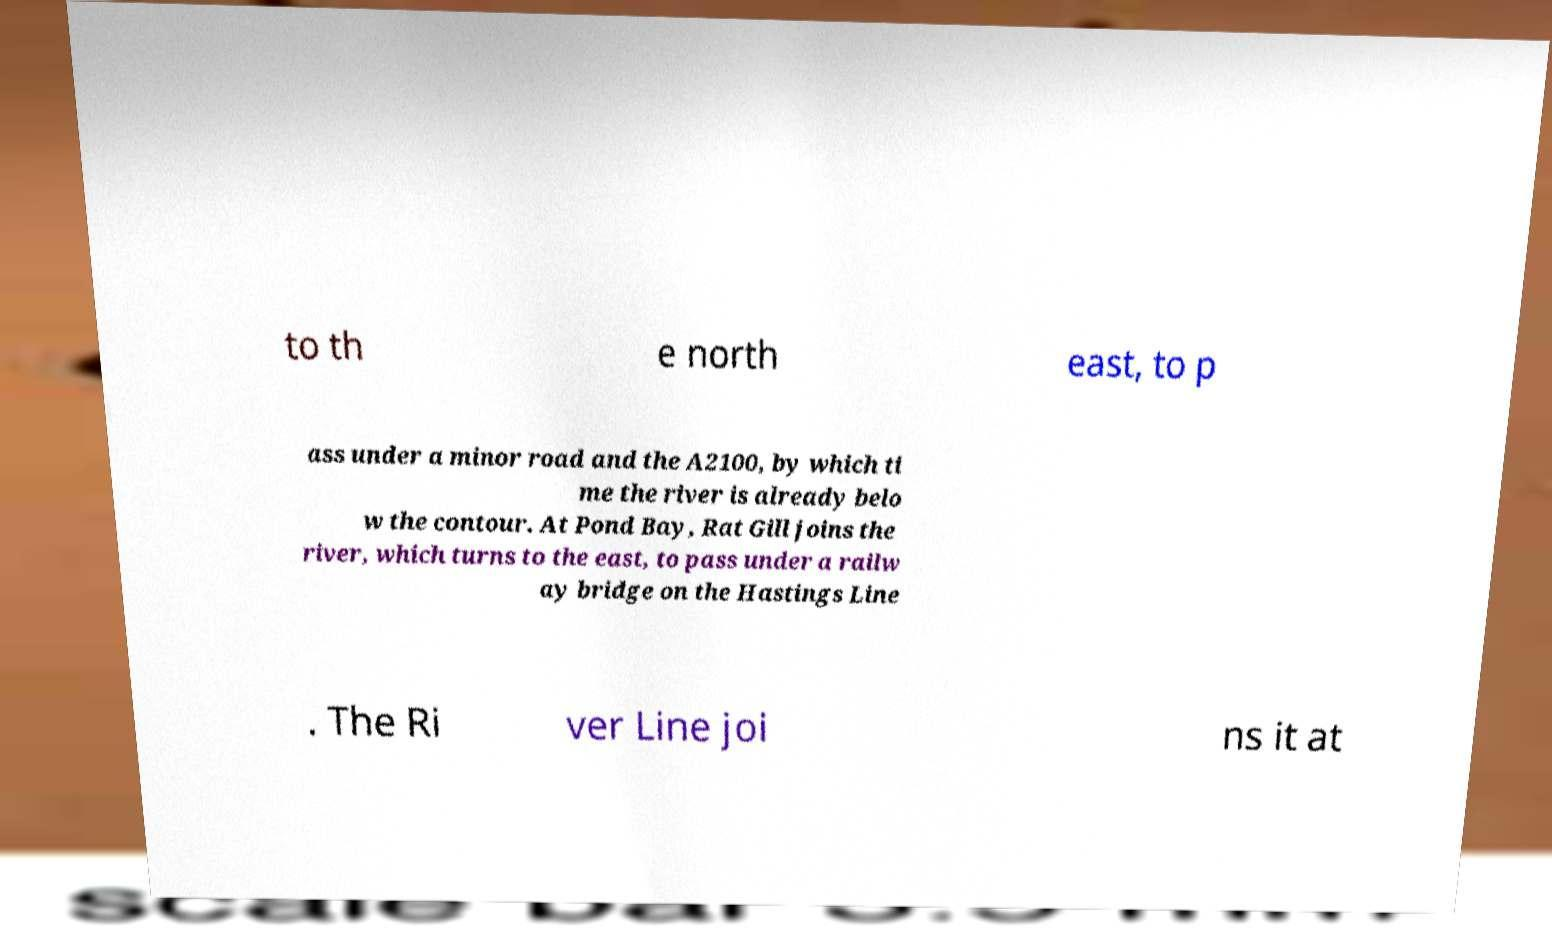Could you extract and type out the text from this image? to th e north east, to p ass under a minor road and the A2100, by which ti me the river is already belo w the contour. At Pond Bay, Rat Gill joins the river, which turns to the east, to pass under a railw ay bridge on the Hastings Line . The Ri ver Line joi ns it at 